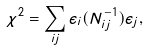<formula> <loc_0><loc_0><loc_500><loc_500>\chi ^ { 2 } = \sum _ { i j } \epsilon _ { i } ( N ^ { - 1 } _ { i j } ) \epsilon _ { j } ,</formula> 